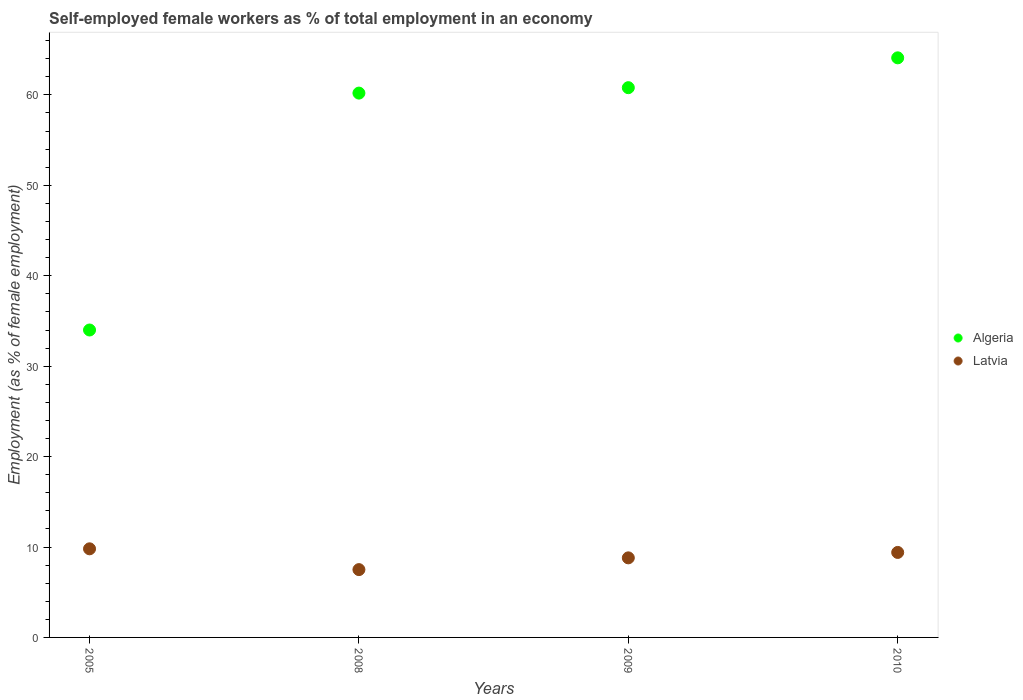Is the number of dotlines equal to the number of legend labels?
Provide a short and direct response. Yes. What is the percentage of self-employed female workers in Algeria in 2010?
Offer a very short reply. 64.1. Across all years, what is the maximum percentage of self-employed female workers in Algeria?
Your response must be concise. 64.1. Across all years, what is the minimum percentage of self-employed female workers in Algeria?
Provide a short and direct response. 34. What is the total percentage of self-employed female workers in Latvia in the graph?
Ensure brevity in your answer.  35.5. What is the difference between the percentage of self-employed female workers in Algeria in 2008 and that in 2009?
Give a very brief answer. -0.6. What is the difference between the percentage of self-employed female workers in Latvia in 2010 and the percentage of self-employed female workers in Algeria in 2008?
Offer a terse response. -50.8. What is the average percentage of self-employed female workers in Latvia per year?
Offer a very short reply. 8.87. In the year 2005, what is the difference between the percentage of self-employed female workers in Algeria and percentage of self-employed female workers in Latvia?
Give a very brief answer. 24.2. In how many years, is the percentage of self-employed female workers in Latvia greater than 8 %?
Ensure brevity in your answer.  3. What is the ratio of the percentage of self-employed female workers in Latvia in 2009 to that in 2010?
Make the answer very short. 0.94. Is the difference between the percentage of self-employed female workers in Algeria in 2008 and 2010 greater than the difference between the percentage of self-employed female workers in Latvia in 2008 and 2010?
Your answer should be very brief. No. What is the difference between the highest and the second highest percentage of self-employed female workers in Latvia?
Your answer should be very brief. 0.4. What is the difference between the highest and the lowest percentage of self-employed female workers in Algeria?
Your answer should be compact. 30.1. Is the sum of the percentage of self-employed female workers in Algeria in 2009 and 2010 greater than the maximum percentage of self-employed female workers in Latvia across all years?
Provide a succinct answer. Yes. Is the percentage of self-employed female workers in Latvia strictly greater than the percentage of self-employed female workers in Algeria over the years?
Give a very brief answer. No. How many dotlines are there?
Offer a terse response. 2. How many years are there in the graph?
Your response must be concise. 4. Are the values on the major ticks of Y-axis written in scientific E-notation?
Your response must be concise. No. What is the title of the graph?
Provide a succinct answer. Self-employed female workers as % of total employment in an economy. What is the label or title of the X-axis?
Provide a short and direct response. Years. What is the label or title of the Y-axis?
Give a very brief answer. Employment (as % of female employment). What is the Employment (as % of female employment) in Algeria in 2005?
Your response must be concise. 34. What is the Employment (as % of female employment) of Latvia in 2005?
Make the answer very short. 9.8. What is the Employment (as % of female employment) of Algeria in 2008?
Your answer should be very brief. 60.2. What is the Employment (as % of female employment) of Algeria in 2009?
Keep it short and to the point. 60.8. What is the Employment (as % of female employment) of Latvia in 2009?
Provide a short and direct response. 8.8. What is the Employment (as % of female employment) of Algeria in 2010?
Offer a terse response. 64.1. What is the Employment (as % of female employment) in Latvia in 2010?
Offer a terse response. 9.4. Across all years, what is the maximum Employment (as % of female employment) in Algeria?
Offer a very short reply. 64.1. Across all years, what is the maximum Employment (as % of female employment) in Latvia?
Make the answer very short. 9.8. What is the total Employment (as % of female employment) of Algeria in the graph?
Your answer should be compact. 219.1. What is the total Employment (as % of female employment) in Latvia in the graph?
Give a very brief answer. 35.5. What is the difference between the Employment (as % of female employment) in Algeria in 2005 and that in 2008?
Keep it short and to the point. -26.2. What is the difference between the Employment (as % of female employment) in Latvia in 2005 and that in 2008?
Provide a succinct answer. 2.3. What is the difference between the Employment (as % of female employment) in Algeria in 2005 and that in 2009?
Your answer should be very brief. -26.8. What is the difference between the Employment (as % of female employment) in Latvia in 2005 and that in 2009?
Offer a terse response. 1. What is the difference between the Employment (as % of female employment) of Algeria in 2005 and that in 2010?
Offer a terse response. -30.1. What is the difference between the Employment (as % of female employment) of Latvia in 2005 and that in 2010?
Offer a terse response. 0.4. What is the difference between the Employment (as % of female employment) of Algeria in 2008 and that in 2010?
Make the answer very short. -3.9. What is the difference between the Employment (as % of female employment) in Latvia in 2008 and that in 2010?
Your answer should be very brief. -1.9. What is the difference between the Employment (as % of female employment) of Latvia in 2009 and that in 2010?
Offer a very short reply. -0.6. What is the difference between the Employment (as % of female employment) of Algeria in 2005 and the Employment (as % of female employment) of Latvia in 2009?
Your response must be concise. 25.2. What is the difference between the Employment (as % of female employment) in Algeria in 2005 and the Employment (as % of female employment) in Latvia in 2010?
Offer a very short reply. 24.6. What is the difference between the Employment (as % of female employment) of Algeria in 2008 and the Employment (as % of female employment) of Latvia in 2009?
Your answer should be compact. 51.4. What is the difference between the Employment (as % of female employment) in Algeria in 2008 and the Employment (as % of female employment) in Latvia in 2010?
Your response must be concise. 50.8. What is the difference between the Employment (as % of female employment) of Algeria in 2009 and the Employment (as % of female employment) of Latvia in 2010?
Keep it short and to the point. 51.4. What is the average Employment (as % of female employment) in Algeria per year?
Your response must be concise. 54.77. What is the average Employment (as % of female employment) of Latvia per year?
Your response must be concise. 8.88. In the year 2005, what is the difference between the Employment (as % of female employment) of Algeria and Employment (as % of female employment) of Latvia?
Offer a very short reply. 24.2. In the year 2008, what is the difference between the Employment (as % of female employment) in Algeria and Employment (as % of female employment) in Latvia?
Provide a succinct answer. 52.7. In the year 2009, what is the difference between the Employment (as % of female employment) in Algeria and Employment (as % of female employment) in Latvia?
Provide a short and direct response. 52. In the year 2010, what is the difference between the Employment (as % of female employment) of Algeria and Employment (as % of female employment) of Latvia?
Offer a very short reply. 54.7. What is the ratio of the Employment (as % of female employment) of Algeria in 2005 to that in 2008?
Your answer should be very brief. 0.56. What is the ratio of the Employment (as % of female employment) of Latvia in 2005 to that in 2008?
Provide a succinct answer. 1.31. What is the ratio of the Employment (as % of female employment) in Algeria in 2005 to that in 2009?
Your answer should be very brief. 0.56. What is the ratio of the Employment (as % of female employment) of Latvia in 2005 to that in 2009?
Provide a succinct answer. 1.11. What is the ratio of the Employment (as % of female employment) in Algeria in 2005 to that in 2010?
Give a very brief answer. 0.53. What is the ratio of the Employment (as % of female employment) of Latvia in 2005 to that in 2010?
Provide a short and direct response. 1.04. What is the ratio of the Employment (as % of female employment) of Latvia in 2008 to that in 2009?
Your response must be concise. 0.85. What is the ratio of the Employment (as % of female employment) in Algeria in 2008 to that in 2010?
Your response must be concise. 0.94. What is the ratio of the Employment (as % of female employment) in Latvia in 2008 to that in 2010?
Keep it short and to the point. 0.8. What is the ratio of the Employment (as % of female employment) of Algeria in 2009 to that in 2010?
Provide a succinct answer. 0.95. What is the ratio of the Employment (as % of female employment) of Latvia in 2009 to that in 2010?
Make the answer very short. 0.94. What is the difference between the highest and the second highest Employment (as % of female employment) in Algeria?
Your response must be concise. 3.3. What is the difference between the highest and the second highest Employment (as % of female employment) of Latvia?
Give a very brief answer. 0.4. What is the difference between the highest and the lowest Employment (as % of female employment) in Algeria?
Your response must be concise. 30.1. 